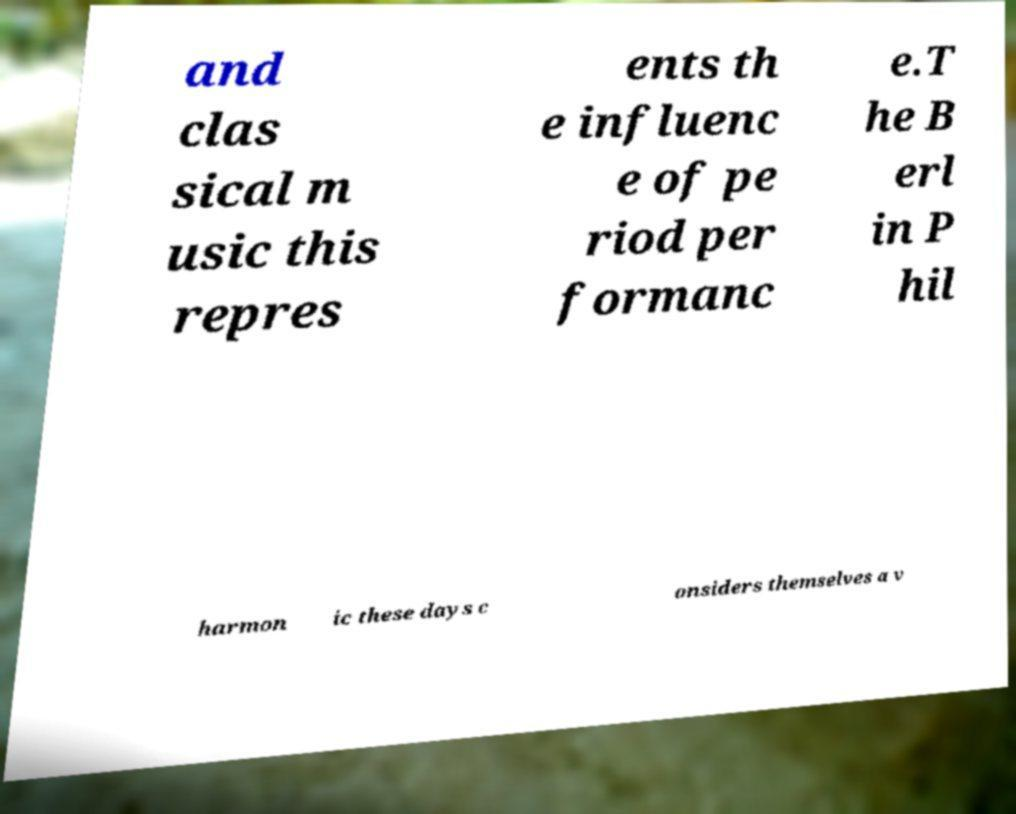Could you extract and type out the text from this image? and clas sical m usic this repres ents th e influenc e of pe riod per formanc e.T he B erl in P hil harmon ic these days c onsiders themselves a v 